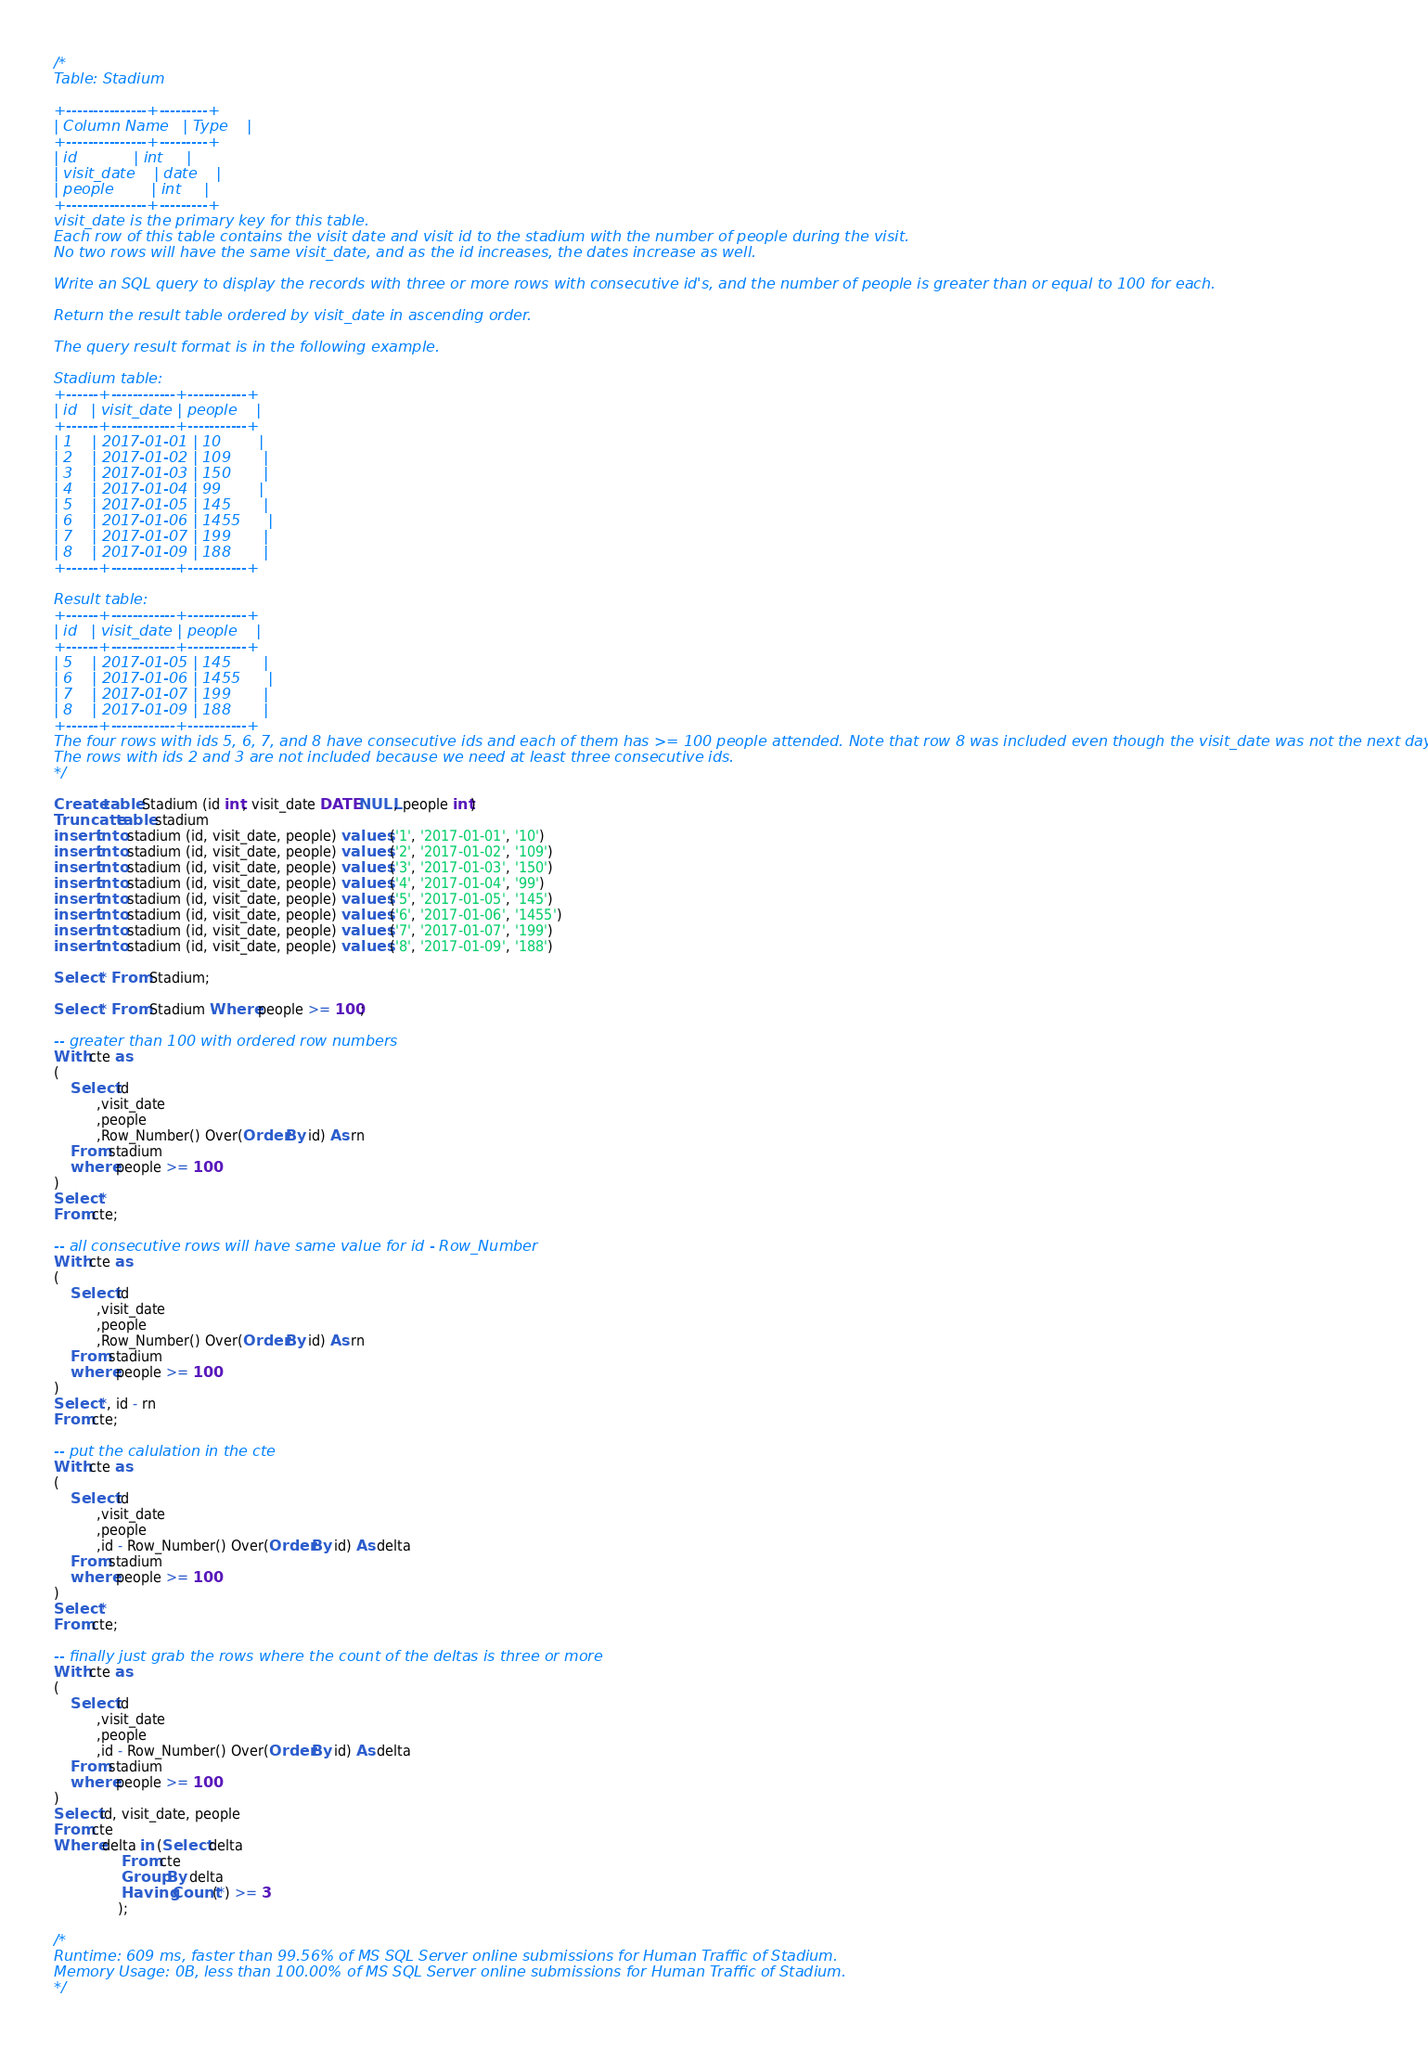<code> <loc_0><loc_0><loc_500><loc_500><_SQL_>/*
Table: Stadium

+---------------+---------+
| Column Name   | Type    |
+---------------+---------+
| id            | int     |
| visit_date    | date    |
| people        | int     |
+---------------+---------+
visit_date is the primary key for this table.
Each row of this table contains the visit date and visit id to the stadium with the number of people during the visit.
No two rows will have the same visit_date, and as the id increases, the dates increase as well.

Write an SQL query to display the records with three or more rows with consecutive id's, and the number of people is greater than or equal to 100 for each.

Return the result table ordered by visit_date in ascending order.

The query result format is in the following example.

Stadium table:
+------+------------+-----------+
| id   | visit_date | people    |
+------+------------+-----------+
| 1    | 2017-01-01 | 10        |
| 2    | 2017-01-02 | 109       |
| 3    | 2017-01-03 | 150       |
| 4    | 2017-01-04 | 99        |
| 5    | 2017-01-05 | 145       |
| 6    | 2017-01-06 | 1455      |
| 7    | 2017-01-07 | 199       |
| 8    | 2017-01-09 | 188       |
+------+------------+-----------+

Result table:
+------+------------+-----------+
| id   | visit_date | people    |
+------+------------+-----------+
| 5    | 2017-01-05 | 145       |
| 6    | 2017-01-06 | 1455      |
| 7    | 2017-01-07 | 199       |
| 8    | 2017-01-09 | 188       |
+------+------------+-----------+
The four rows with ids 5, 6, 7, and 8 have consecutive ids and each of them has >= 100 people attended. Note that row 8 was included even though the visit_date was not the next day after row 7.
The rows with ids 2 and 3 are not included because we need at least three consecutive ids.
*/

Create table Stadium (id int, visit_date DATE NULL, people int)
Truncate table stadium
insert into stadium (id, visit_date, people) values ('1', '2017-01-01', '10')
insert into stadium (id, visit_date, people) values ('2', '2017-01-02', '109')
insert into stadium (id, visit_date, people) values ('3', '2017-01-03', '150')
insert into stadium (id, visit_date, people) values ('4', '2017-01-04', '99')
insert into stadium (id, visit_date, people) values ('5', '2017-01-05', '145')
insert into stadium (id, visit_date, people) values ('6', '2017-01-06', '1455')
insert into stadium (id, visit_date, people) values ('7', '2017-01-07', '199')
insert into stadium (id, visit_date, people) values ('8', '2017-01-09', '188')

Select * From Stadium;

Select * From Stadium Where people >= 100;

-- greater than 100 with ordered row numbers
With cte as
(
    Select id
          ,visit_date
          ,people
          ,Row_Number() Over(Order By id) As rn
    From stadium
    where people >= 100
)
Select *
From cte;

-- all consecutive rows will have same value for id - Row_Number
With cte as
(
    Select id
          ,visit_date
          ,people
          ,Row_Number() Over(Order By id) As rn
    From stadium
    where people >= 100
)
Select *, id - rn
From cte;

-- put the calulation in the cte
With cte as
(
    Select id
          ,visit_date
          ,people
          ,id - Row_Number() Over(Order By id) As delta
    From stadium
    where people >= 100
)
Select *
From cte;

-- finally just grab the rows where the count of the deltas is three or more
With cte as
(
    Select id
          ,visit_date
          ,people
          ,id - Row_Number() Over(Order By id) As delta
    From stadium
    where people >= 100
)
Select id, visit_date, people
From cte
Where delta in (Select delta
                From cte
                Group By delta
                Having Count(*) >= 3 
               );

/*
Runtime: 609 ms, faster than 99.56% of MS SQL Server online submissions for Human Traffic of Stadium.
Memory Usage: 0B, less than 100.00% of MS SQL Server online submissions for Human Traffic of Stadium.
*/



</code> 